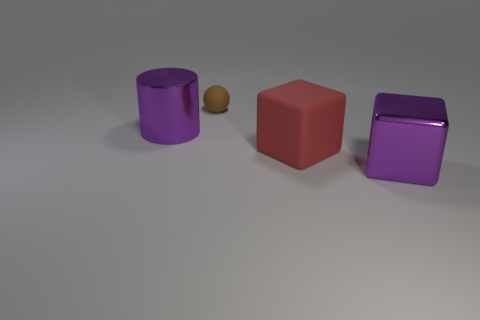Subtract all red blocks. How many blocks are left? 1 Subtract 1 cylinders. How many cylinders are left? 0 Add 1 cubes. How many objects exist? 5 Subtract 1 purple cylinders. How many objects are left? 3 Subtract all gray cubes. Subtract all red balls. How many cubes are left? 2 Subtract all green spheres. How many yellow cylinders are left? 0 Subtract all small matte objects. Subtract all brown matte objects. How many objects are left? 2 Add 3 brown things. How many brown things are left? 4 Add 2 tiny purple balls. How many tiny purple balls exist? 2 